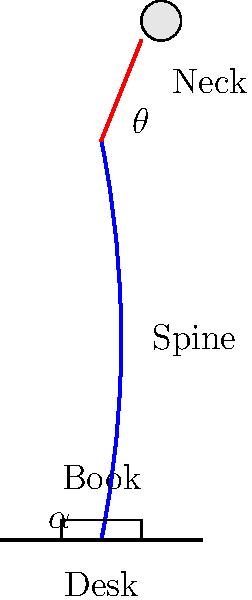In the biomechanical analysis of proper reading posture, what is the recommended neck angle ($\theta$) and the ideal angle ($\alpha$) between the line of sight and the reading material for optimal spine alignment and reduced strain? To determine the proper reading posture for optimal spine alignment and reduced strain, we need to consider several biomechanical factors:

1. Spine alignment: The spine should maintain its natural S-curve to distribute weight evenly and minimize stress on the vertebrae.

2. Neck angle ($\theta$): 
   - The neck should be in a neutral position to reduce strain on the cervical spine.
   - The recommended neck angle ($\theta$) is between 0° and 15° from vertical.
   - This slight forward tilt allows for a comfortable viewing angle without excessive strain.

3. Line of sight angle ($\alpha$):
   - The angle between the line of sight and the reading material should be approximately 60°.
   - This angle helps maintain a more upright head position and reduces the need for excessive neck flexion.

4. Eye-to-task distance:
   - The ideal distance between the eyes and the reading material is about 40-50 cm (16-20 inches).
   - This distance allows for clear vision without straining the eyes or neck.

5. Posture adjustments:
   - Use a bookstand or adjust the desk angle to bring the reading material closer to eye level.
   - This reduces the need to bend the neck forward and helps maintain proper spine alignment.

6. Frequent breaks and position changes:
   - Take regular breaks to move and stretch, preventing muscle fatigue and strain.

By maintaining a neck angle ($\theta$) of 0-15° and a line of sight angle ($\alpha$) of approximately 60°, readers can achieve optimal spine alignment and reduce strain during extended reading sessions.
Answer: $\theta = 0°-15°$, $\alpha \approx 60°$ 